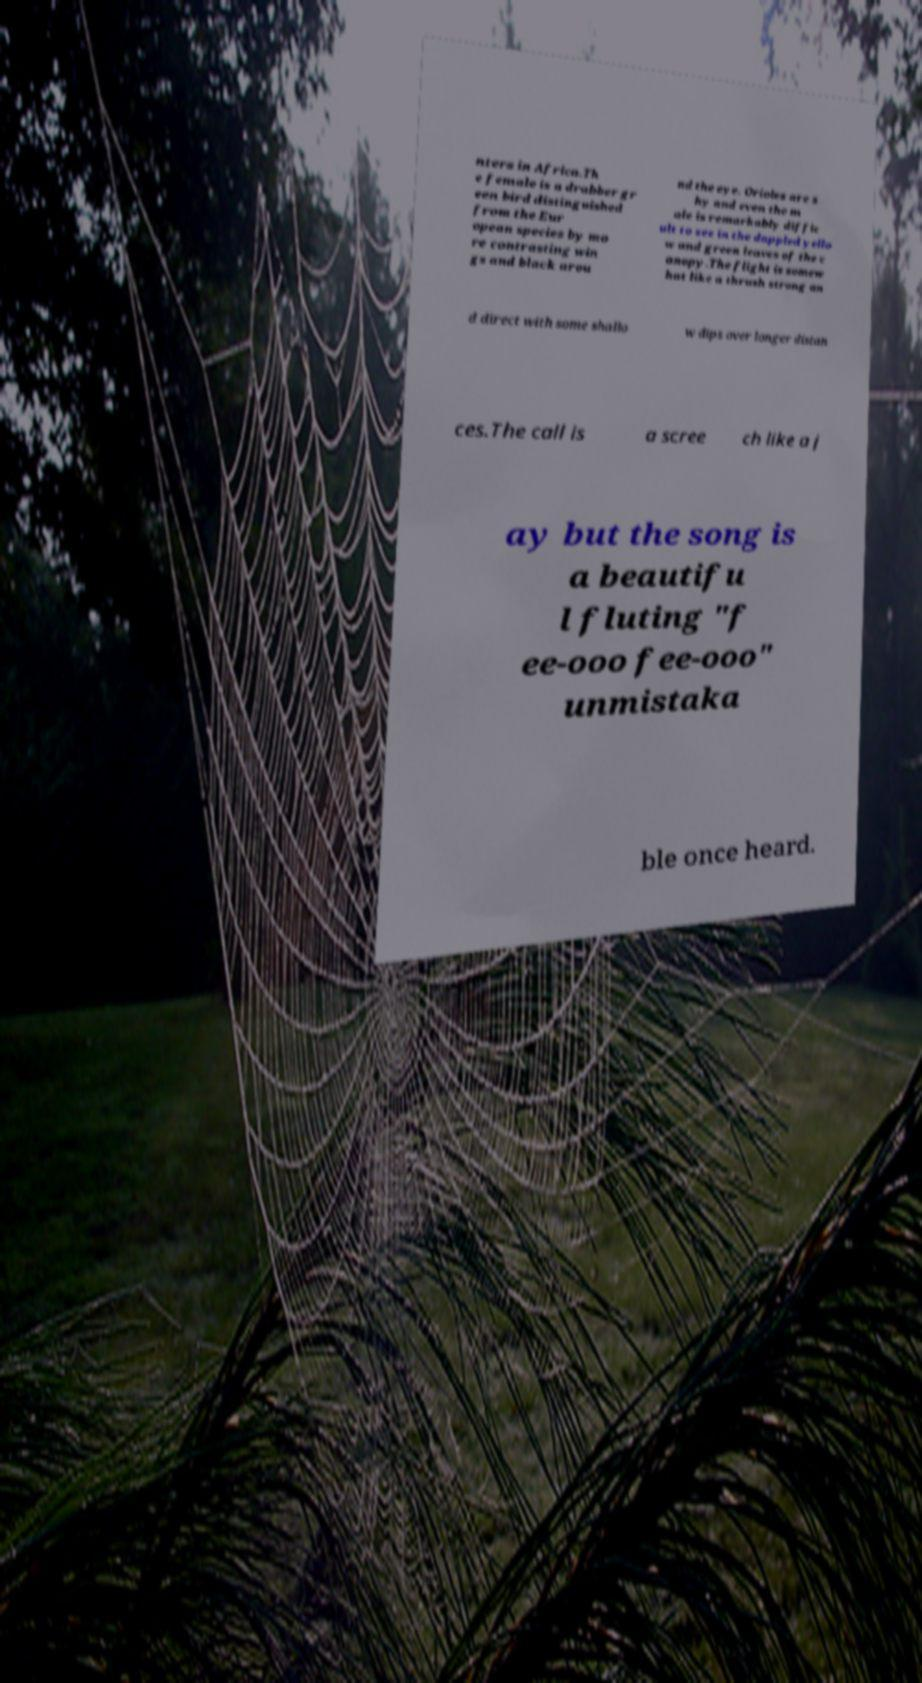Please read and relay the text visible in this image. What does it say? nters in Africa.Th e female is a drabber gr een bird distinguished from the Eur opean species by mo re contrasting win gs and black arou nd the eye. Orioles are s hy and even the m ale is remarkably diffic ult to see in the dappled yello w and green leaves of the c anopy.The flight is somew hat like a thrush strong an d direct with some shallo w dips over longer distan ces.The call is a scree ch like a j ay but the song is a beautifu l fluting "f ee-ooo fee-ooo" unmistaka ble once heard. 